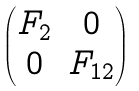<formula> <loc_0><loc_0><loc_500><loc_500>\begin{pmatrix} F _ { 2 } & 0 \\ 0 & F _ { 1 2 } \end{pmatrix}</formula> 